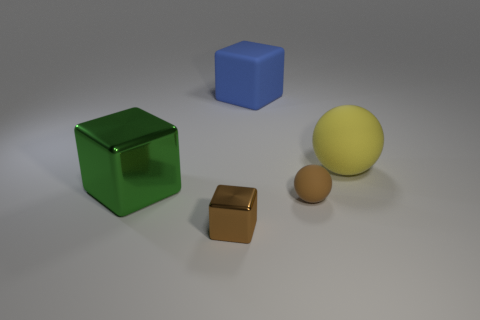Subtract all big cubes. How many cubes are left? 1 Subtract all brown cubes. How many cubes are left? 2 Add 1 tiny metallic objects. How many objects exist? 6 Subtract all cubes. How many objects are left? 2 Subtract 2 balls. How many balls are left? 0 Add 3 green blocks. How many green blocks are left? 4 Add 3 big green cylinders. How many big green cylinders exist? 3 Subtract 0 cyan blocks. How many objects are left? 5 Subtract all purple cubes. Subtract all brown spheres. How many cubes are left? 3 Subtract all large green metal objects. Subtract all small metallic blocks. How many objects are left? 3 